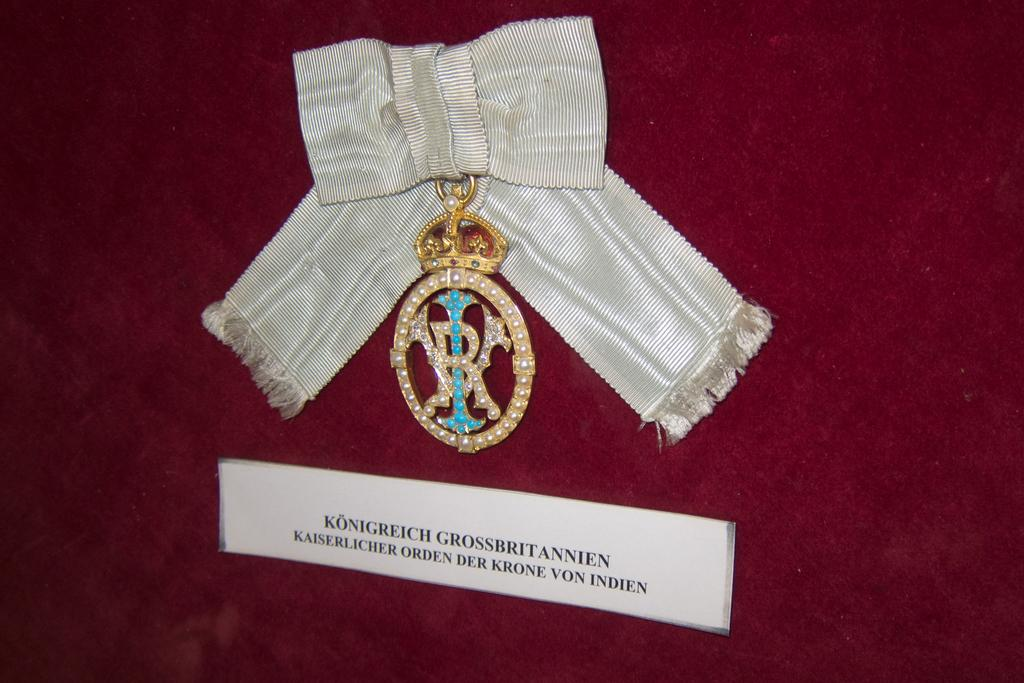What is present in the image that signifies an achievement or recognition? There is a badge in the image. What else is present in the image that might be related to the badge? There is a ribbon in the image. What is the color of the surface on which the badge is hung? The badge is hung on a maroon-colored surface. What additional information can be found in the image? There is text on a paper stuck to the surface. How many horses are running in the image? There are no horses present in the image. What type of rest can be seen being taken by the person in the image? There is no person present in the image, so it is not possible to determine if they are taking rest or not. 